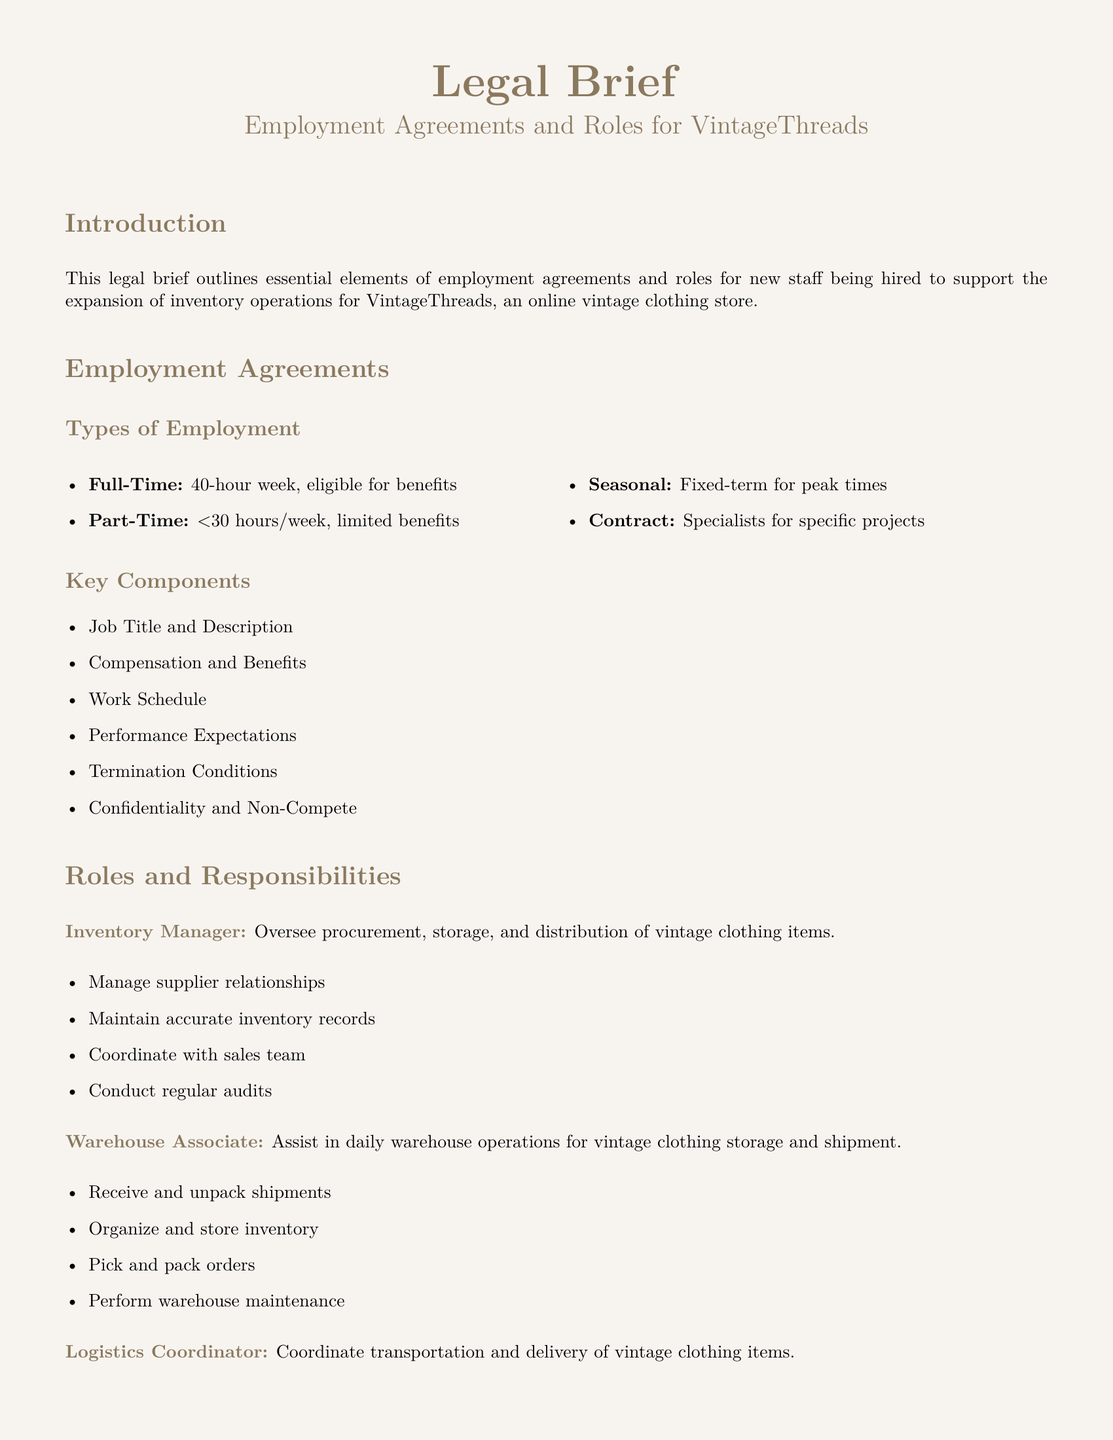What are the types of employment? The document lists employment types including Full-Time, Part-Time, Seasonal, and Contract.
Answer: Full-Time, Part-Time, Seasonal, Contract What is the job title for overseeing inventory operations? The document specifies the title responsible for overseeing procurement, storage, and distribution of vintage clothing items.
Answer: Inventory Manager How many hours per week define a Full-Time position? The document states that a Full-Time position consists of a specific number of hours.
Answer: 40-hour What is a key component of employment agreements mentioned in the document? The document outlines several key components for employment agreements, one of which includes Job Title and Description.
Answer: Job Title and Description What responsibility does the Warehouse Associate have? The document describes duties of the Warehouse Associate, including assisting in daily warehouse operations.
Answer: Assist in daily warehouse operations What role coordinates transportation and delivery of items? The document identifies the title responsible for scheduling and tracking shipments.
Answer: Logistics Coordinator How is confidentiality addressed in employment agreements? The document mentions that confidentiality is one of the key components listed in employment agreements.
Answer: Confidentiality How often should inventory audits be conducted according to the roles outlined? The document includes conducting regular audits as a responsibility of the Inventory Manager.
Answer: Regular audits What is the conclusion of the document? The document provides a summary that emphasizes clarity in employment agreements for effective management.
Answer: Comprehensive overview of necessary employment agreements and detailed roles and responsibilities for new staff 